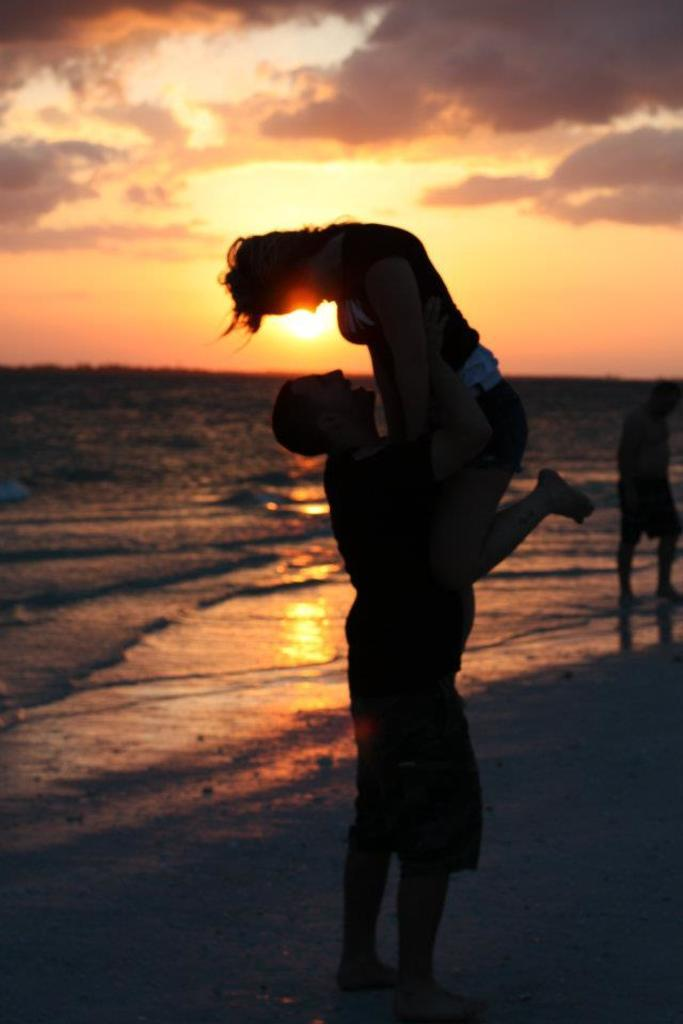How many people are present in the image? There are three people in the image. What is one of the people doing in the image? A man is lifting a woman with his hands on the ground. What can be seen near the ground in the image? There is water visible near the ground. What is visible in the background of the image? The sky is visible in the background of the image. How many hills can be seen in the image? There are no hills visible in the image. What type of knee injury does the stranger have in the image? There is no stranger present in the image, and therefore no knee injury can be observed. 